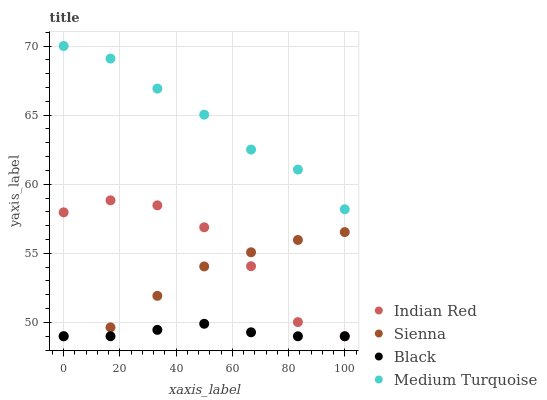Does Black have the minimum area under the curve?
Answer yes or no. Yes. Does Medium Turquoise have the maximum area under the curve?
Answer yes or no. Yes. Does Medium Turquoise have the minimum area under the curve?
Answer yes or no. No. Does Black have the maximum area under the curve?
Answer yes or no. No. Is Black the smoothest?
Answer yes or no. Yes. Is Indian Red the roughest?
Answer yes or no. Yes. Is Medium Turquoise the smoothest?
Answer yes or no. No. Is Medium Turquoise the roughest?
Answer yes or no. No. Does Sienna have the lowest value?
Answer yes or no. Yes. Does Medium Turquoise have the lowest value?
Answer yes or no. No. Does Medium Turquoise have the highest value?
Answer yes or no. Yes. Does Black have the highest value?
Answer yes or no. No. Is Indian Red less than Medium Turquoise?
Answer yes or no. Yes. Is Medium Turquoise greater than Sienna?
Answer yes or no. Yes. Does Black intersect Indian Red?
Answer yes or no. Yes. Is Black less than Indian Red?
Answer yes or no. No. Is Black greater than Indian Red?
Answer yes or no. No. Does Indian Red intersect Medium Turquoise?
Answer yes or no. No. 